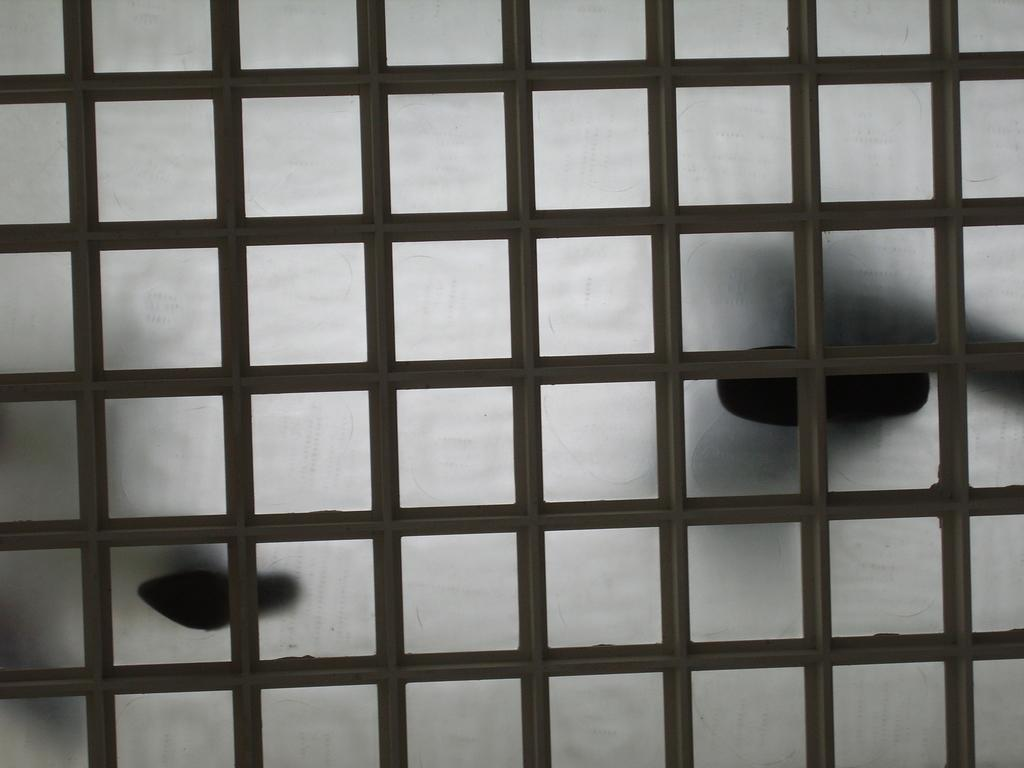What type of floor is visible in the image? There is a glass floor in the image. What colors are present on the glass floor? The glass floor is white and black in color. How many people are standing on the glass floor? Two persons are standing on the glass floor. What type of scissors can be seen cutting through the glass floor in the image? There are no scissors present in the image, and the glass floor is not being cut. 